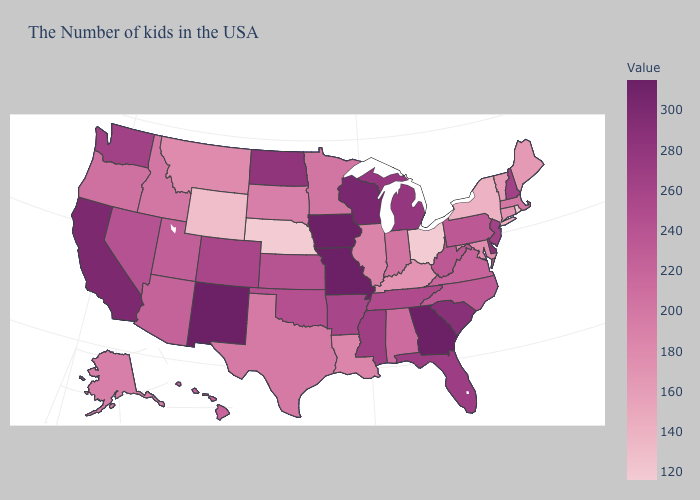Does Rhode Island have the lowest value in the USA?
Concise answer only. Yes. Does Wyoming have the lowest value in the West?
Concise answer only. Yes. Which states hav the highest value in the MidWest?
Keep it brief. Missouri, Iowa. Does Oklahoma have a higher value than Minnesota?
Keep it brief. Yes. Does Oregon have a lower value than North Carolina?
Keep it brief. Yes. Which states have the lowest value in the Northeast?
Give a very brief answer. Rhode Island. Which states hav the highest value in the MidWest?
Quick response, please. Missouri, Iowa. Which states hav the highest value in the South?
Quick response, please. Georgia. Does New Mexico have the highest value in the USA?
Write a very short answer. Yes. 